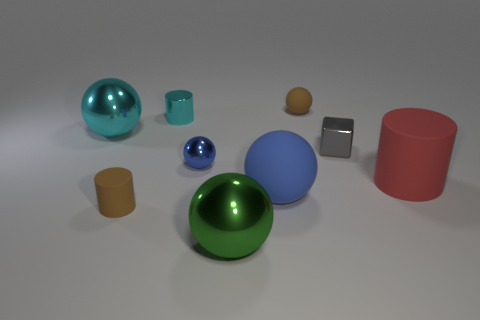There is another brown cylinder that is the same material as the large cylinder; what size is it?
Offer a terse response. Small. There is a ball in front of the brown cylinder; how many gray metal cubes are on the left side of it?
Your answer should be very brief. 0. There is a small shiny sphere; how many brown rubber objects are to the left of it?
Keep it short and to the point. 1. There is a large object left of the tiny ball that is in front of the brown thing behind the tiny cyan shiny thing; what is its color?
Provide a short and direct response. Cyan. There is a small sphere to the left of the green shiny object; is it the same color as the big rubber object that is on the left side of the small gray metallic block?
Keep it short and to the point. Yes. The brown matte thing in front of the matte cylinder behind the big blue matte object is what shape?
Offer a very short reply. Cylinder. Is there a brown cylinder of the same size as the brown rubber ball?
Offer a terse response. Yes. How many other green shiny things have the same shape as the green metallic object?
Keep it short and to the point. 0. Are there the same number of rubber cylinders to the right of the small rubber ball and small gray metallic blocks in front of the big red matte object?
Make the answer very short. No. Are there any small metallic cubes?
Your response must be concise. Yes. 